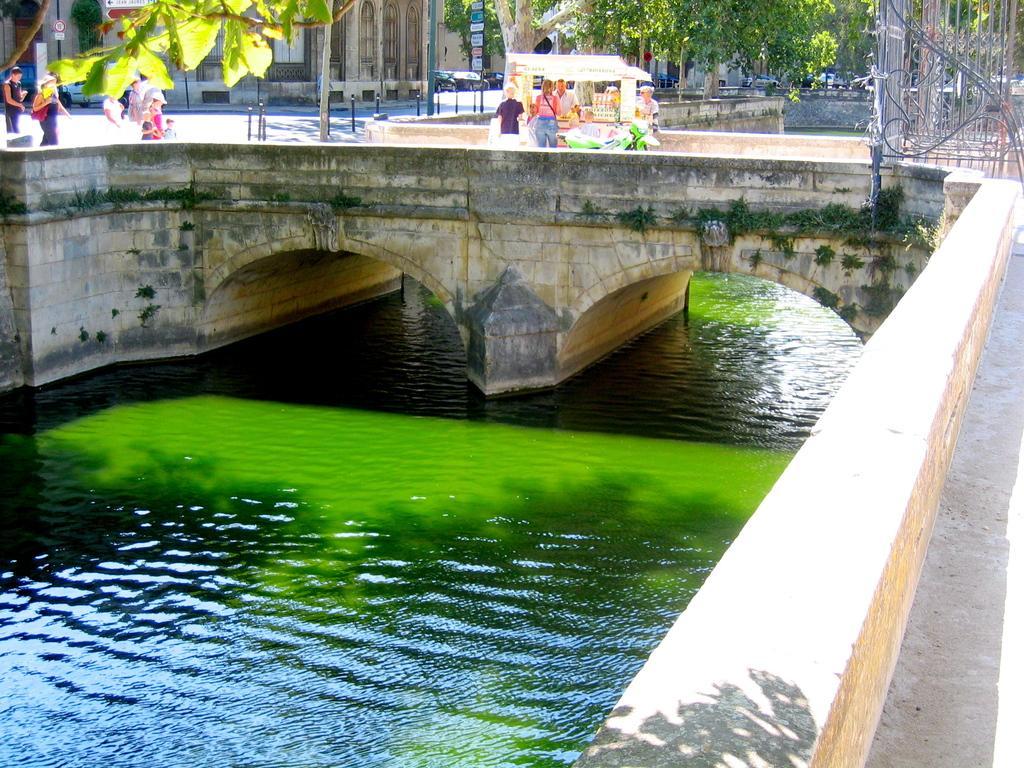Describe this image in one or two sentences. In this image we can see bridgewater, persons, shop, pole, boards, trees, sign boards and buildings. 